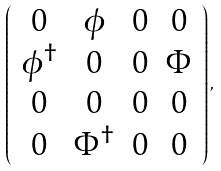<formula> <loc_0><loc_0><loc_500><loc_500>\left ( \begin{array} { c c c c } 0 & \phi & 0 & 0 \\ \phi ^ { \dagger } & 0 & 0 & \Phi \\ 0 & 0 & 0 & 0 \\ 0 & \Phi ^ { \dagger } & 0 & 0 \end{array} \right ) ,</formula> 